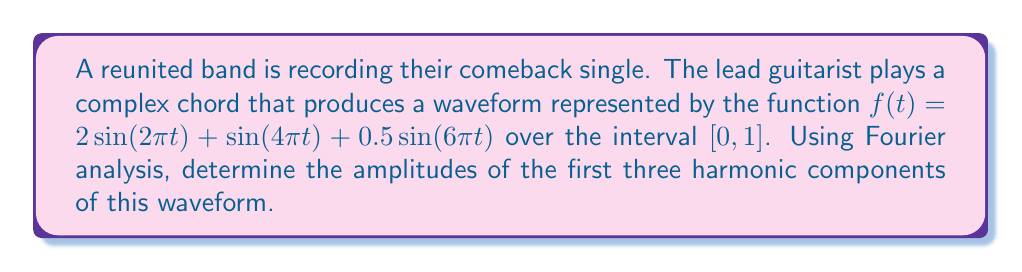Give your solution to this math problem. To analyze the harmonic series of this complex waveform using Fourier analysis, we'll follow these steps:

1) Recall that the Fourier series of a periodic function $f(t)$ with period $T$ is given by:

   $f(t) = a_0 + \sum_{n=1}^{\infty} [a_n \cos(n\omega t) + b_n \sin(n\omega t)]$

   where $\omega = \frac{2\pi}{T}$ is the fundamental frequency.

2) In our case, $f(t) = 2\sin(2\pi t) + \sin(4\pi t) + 0.5\sin(6\pi t)$, which is already in the form of a Fourier series with only sine terms.

3) Comparing our function to the general Fourier series form, we can identify:

   - $a_0 = 0$ (no constant term)
   - $a_n = 0$ for all $n$ (no cosine terms)
   - $b_1 = 2$ (coefficient of $\sin(2\pi t)$)
   - $b_2 = 1$ (coefficient of $\sin(4\pi t)$)
   - $b_3 = 0.5$ (coefficient of $\sin(6\pi t)$)

4) The amplitude of each harmonic component is given by $\sqrt{a_n^2 + b_n^2}$. Since $a_n = 0$ for all $n$, the amplitudes are simply $|b_n|$.

5) Therefore, the amplitudes of the first three harmonic components are:

   - 1st harmonic: $|b_1| = 2$
   - 2nd harmonic: $|b_2| = 1$
   - 3rd harmonic: $|b_3| = 0.5$
Answer: $2, 1, 0.5$ 